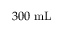Convert formula to latex. <formula><loc_0><loc_0><loc_500><loc_500>3 0 0 m L</formula> 